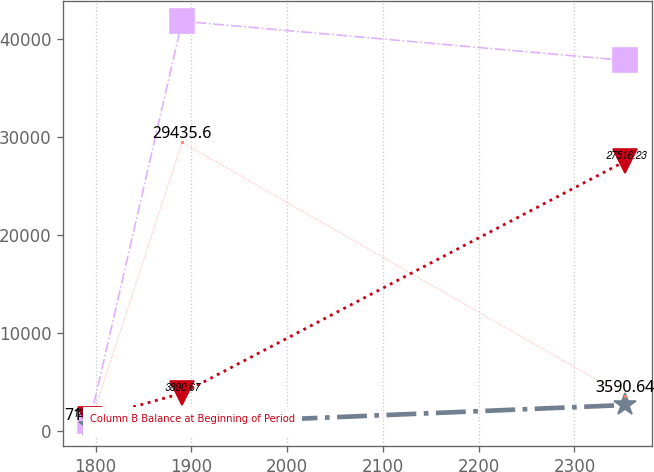Convert chart. <chart><loc_0><loc_0><loc_500><loc_500><line_chart><ecel><fcel>Column D Other Changes Deductions (1)<fcel>Column E Balance at End of Period<fcel>Column C Additions Charged to Income<fcel>Column B Balance at Beginning of Period<nl><fcel>1793.96<fcel>1058.41<fcel>589.18<fcel>718.98<fcel>1265.61<nl><fcel>1890.24<fcel>41761.8<fcel>799.36<fcel>29435.6<fcel>3890.67<nl><fcel>2353.08<fcel>37766.7<fcel>2691.01<fcel>3590.64<fcel>27516.2<nl></chart> 